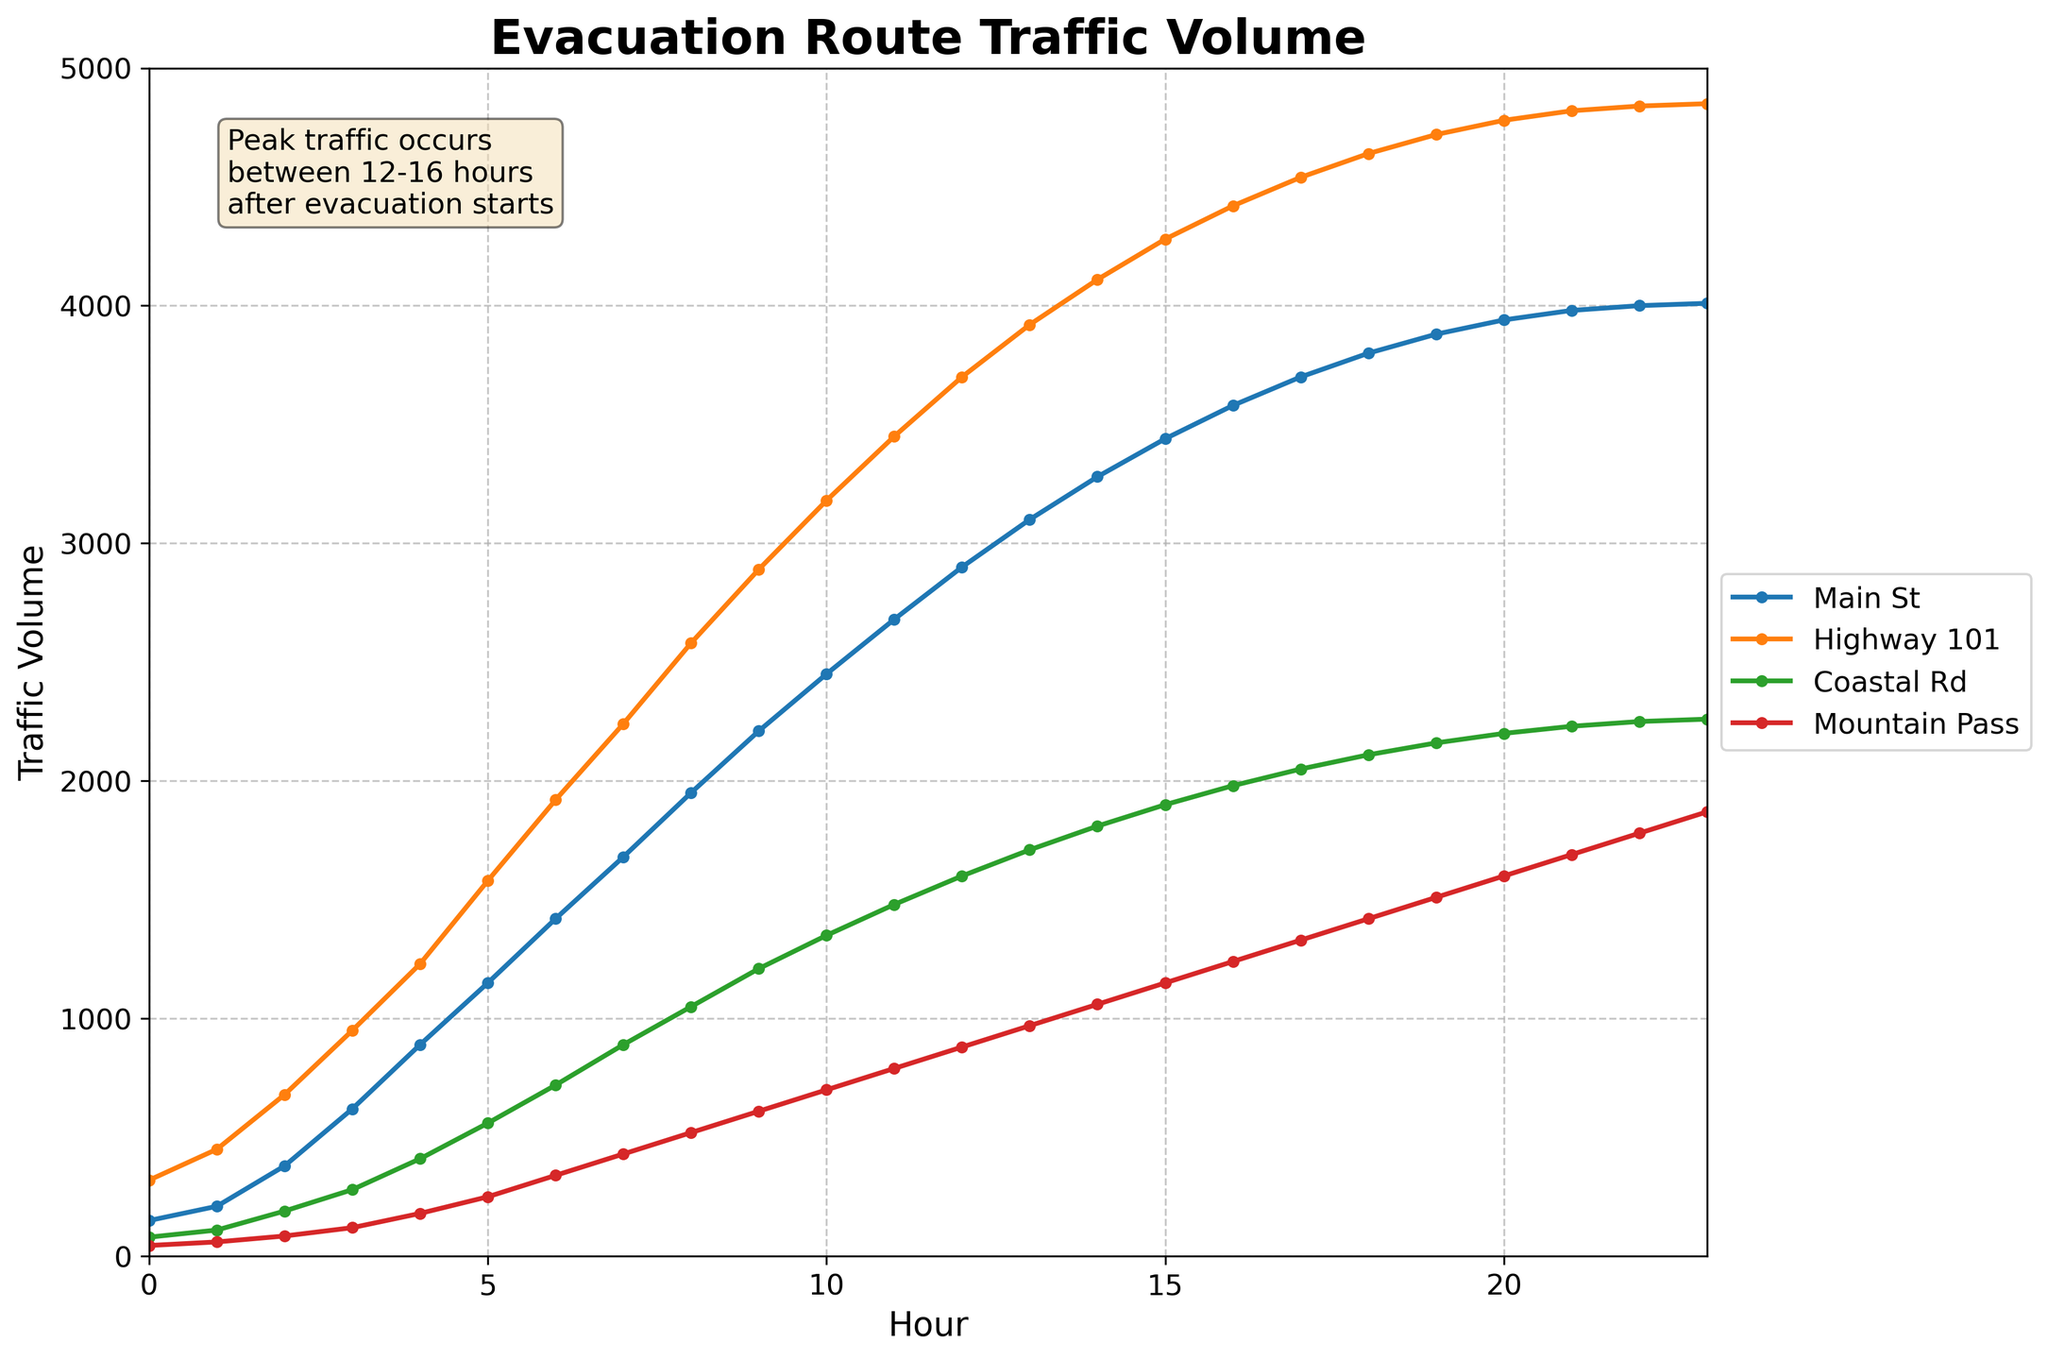What's the total traffic volume on Main St during the first 3 hours? Add the traffic volumes of Main St for the hours 0, 1, and 2: 150 + 210 + 380 = 740
Answer: 740 Which route shows the greatest increase in traffic volume between hour 0 and hour 23? To find the greatest increase, calculate the difference between the traffic volume at hour 23 and hour 0 for each route. Main St: 4010 - 150 = 3860, Highway 101: 4850 - 320 = 4530, Coastal Rd: 2260 - 80 = 2180, Mountain Pass: 1870 - 45 = 1825. The greatest increase is for Highway 101.
Answer: Highway 101 At what hour does Highway 101 reach its peak traffic volume? From the line chart, observe the traffic volume for Highway 101 across all hours. The peak traffic volume is 4850 at hour 23.
Answer: 23 On which evacuation route does traffic volume remain below 500 for the longest period? Compare the traffic volumes for Main St, Highway 101, Coastal Rd, and Mountain Pass. Identify the route where the volume stays below 500 for the longest time. Main St and Highway 101 exceed 500 early. Coastal Rd and Mountain Pass are below 500 until hour 5: Coastal Rd: hour 0-4, Mountain Pass: hour 0-4. Both remain below 500 for 5 hours, but tie with Coastal Rd.
Answer: Coastal Rd and Mountain Pass What is the traffic volume difference between the peak hours of Coastal Rd and Mountain Pass? Find the peak volumes: Coastal Rd reaches 2260 at hour 23, and Mountain Pass reaches 1870 at hour 23. The difference is 2260 - 1870 = 390.
Answer: 390 Which route has the slowest increase in traffic volume from hour 0 to hour 4? Calculate the difference in traffic volume from hour 0 to hour 4 for each route: Main St: 890 - 150 = 740, Highway 101: 1230 - 320 = 910, Coastal Rd: 410 - 80 = 330, Mountain Pass: 180 - 45 = 135. The slowest increase is for Mountain Pass.
Answer: Mountain Pass What is the average traffic volume for Highway 101 between hours 10 and 15? Add the traffic volumes of Highway 101 from hour 10 to hour 15 and divide by the number of hours: (3180 + 3450 + 3700 + 3920 + 4110 + 4280) / 6 = 22640 / 6 = 3773.33
Answer: 3773.33 During which hours does Main St have a higher traffic volume than Coastal Rd? Compare the values of Main St and Coastal Rd hourly. Main St traffic volume exceeds Coastal Rd from hour 2 (380 vs. 190) to hour 23 (4010 vs. 2260).
Answer: 2-23 Is there an hour where all routes have increasing traffic volumes at the same rate? For each hour, calculate the rate of increase for each route: Main St: (t2 - t1) / (t1), Highway 101: (t2 - t1) / (t1), etc. Check if the rates are equal for any hour. No hour shows equal rate; they have different growth patterns.
Answer: No 